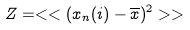<formula> <loc_0><loc_0><loc_500><loc_500>Z = < < ( x _ { n } ( i ) - \overline { x } ) ^ { 2 } > ></formula> 